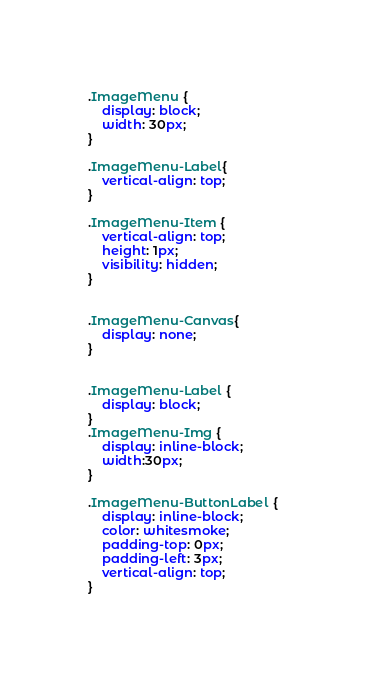<code> <loc_0><loc_0><loc_500><loc_500><_CSS_>
.ImageMenu {
    display: block;
    width: 30px;
}

.ImageMenu-Label{
    vertical-align: top;
}

.ImageMenu-Item {
    vertical-align: top;
    height: 1px;
    visibility: hidden;
}


.ImageMenu-Canvas{
    display: none;
}


.ImageMenu-Label {
    display: block;
}
.ImageMenu-Img {
    display: inline-block;
    width:30px;
}

.ImageMenu-ButtonLabel {
    display: inline-block;
    color: whitesmoke;
    padding-top: 0px;
    padding-left: 3px;
    vertical-align: top;
}</code> 